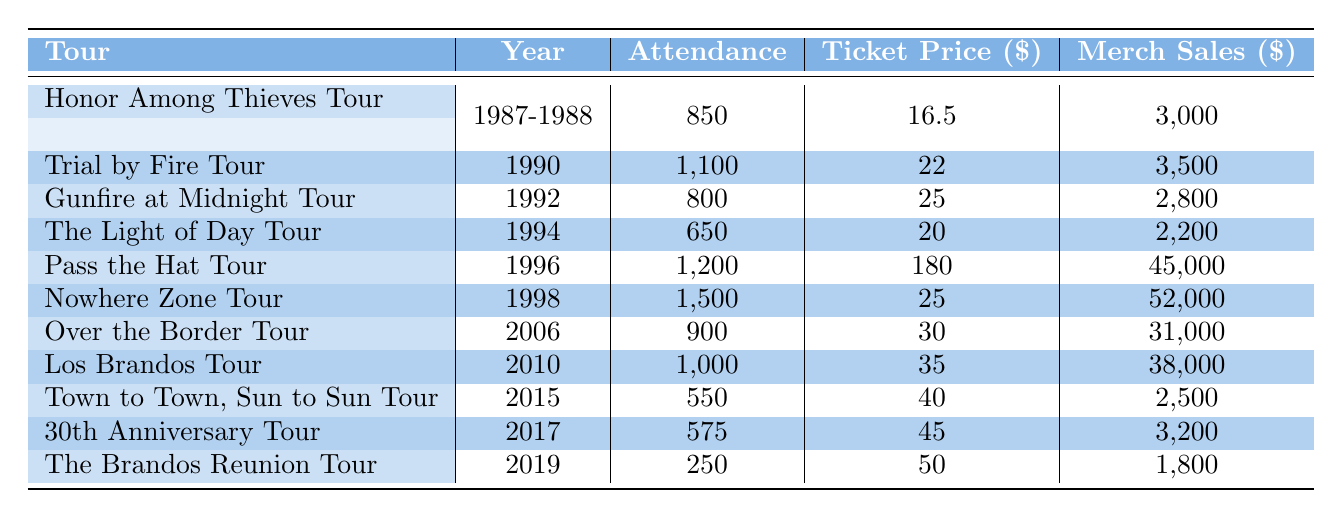What was the total attendance for the Honor Among Thieves Tour? The total attendance for the Honor Among Thieves Tour includes both years 1987 and 1988. The attendance for 1987 is 350 and for 1988 is 500. Therefore, we sum these values: 350 + 500 = 850.
Answer: 850 Which tour had the highest merch sales? To determine which tour had the highest merch sales, we look at the "Merch Sales" column for all tours. The "Nowhere Zone Tour" in 1998 had the highest merch sales of 52,000.
Answer: Nowhere Zone Tour Was the attendance for the 30th Anniversary Tour greater than that of the Town to Town, Sun to Sun Tour? The attendance for the 30th Anniversary Tour in 2017 is 575, and for the Town to Town, Sun to Sun Tour in 2015, it is 550. Since 575 is greater than 550, the statement is true.
Answer: Yes What was the average ticket price for tours from the 1990s? The tours from the 1990s are the Trial by Fire Tour, Gunfire at Midnight Tour, The Light of Day Tour, and Pass the Hat Tour. Their ticket prices are 22, 25, 20, and 180, respectively. We calculate the average: (22 + 25 + 20 + 180) = 247, and then divide by the number of tours, which is 4: 247 / 4 = 61.75.
Answer: 61.75 Did The Brandos perform at more venues in the 2000s than in the 1990s? In the 1990s, The Brandos performed at four venues (Trial by Fire, Gunfire at Midnight, The Light of Day, Pass the Hat). In the 2000s, they performed at three venues (Nowhere Zone, Over the Border, Los Brandos). Since four is greater than three, the statement is false.
Answer: No 